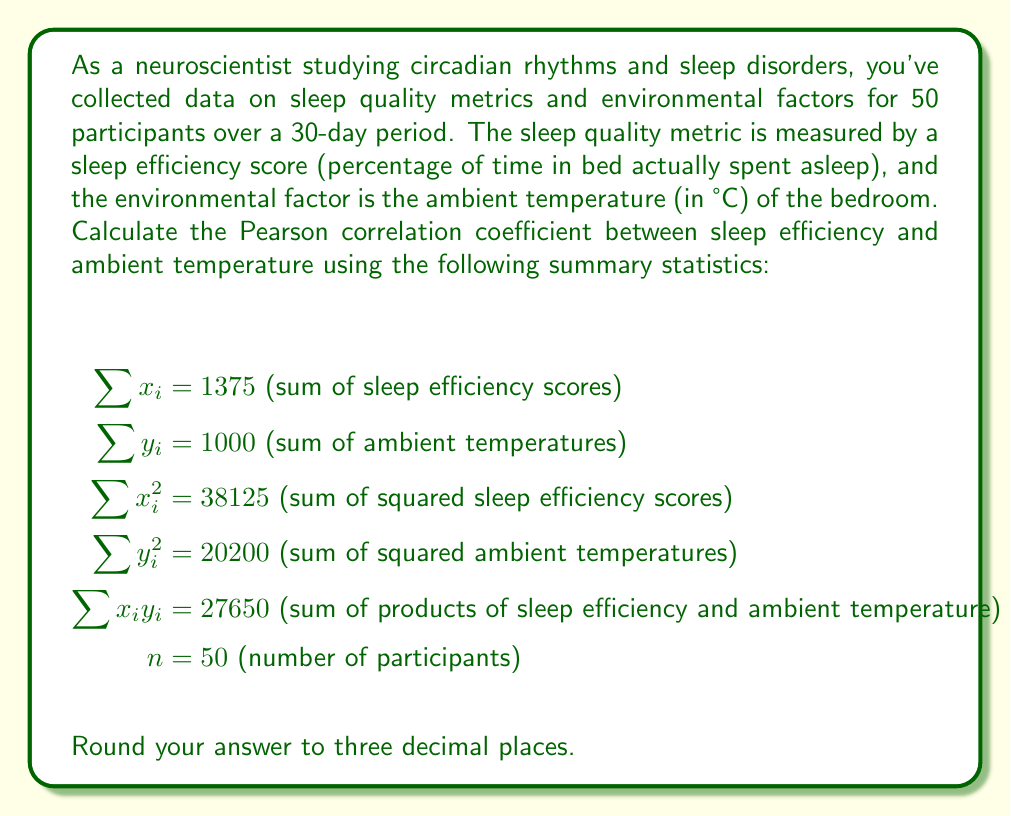What is the answer to this math problem? To calculate the Pearson correlation coefficient, we'll use the formula:

$$r = \frac{n\sum x_iy_i - (\sum x_i)(\sum y_i)}{\sqrt{[n\sum x_i^2 - (\sum x_i)^2][n\sum y_i^2 - (\sum y_i)^2]}}$$

Let's break this down step by step:

1. Calculate $n\sum x_iy_i$:
   $50 \times 27650 = 1382500$

2. Calculate $(\sum x_i)(\sum y_i)$:
   $1375 \times 1000 = 1375000$

3. Calculate the numerator:
   $1382500 - 1375000 = 7500$

4. Calculate $n\sum x_i^2$:
   $50 \times 38125 = 1906250$

5. Calculate $(\sum x_i)^2$:
   $1375^2 = 1890625$

6. Calculate $n\sum y_i^2$:
   $50 \times 20200 = 1010000$

7. Calculate $(\sum y_i)^2$:
   $1000^2 = 1000000$

8. Calculate the denominator:
   $\sqrt{[1906250 - 1890625][1010000 - 1000000]}$
   $= \sqrt{[15625][10000]}$
   $= \sqrt{156250000}$
   $= 12500$

9. Finally, calculate the correlation coefficient:
   $r = \frac{7500}{12500} = 0.6$
Answer: $r = 0.600$ 